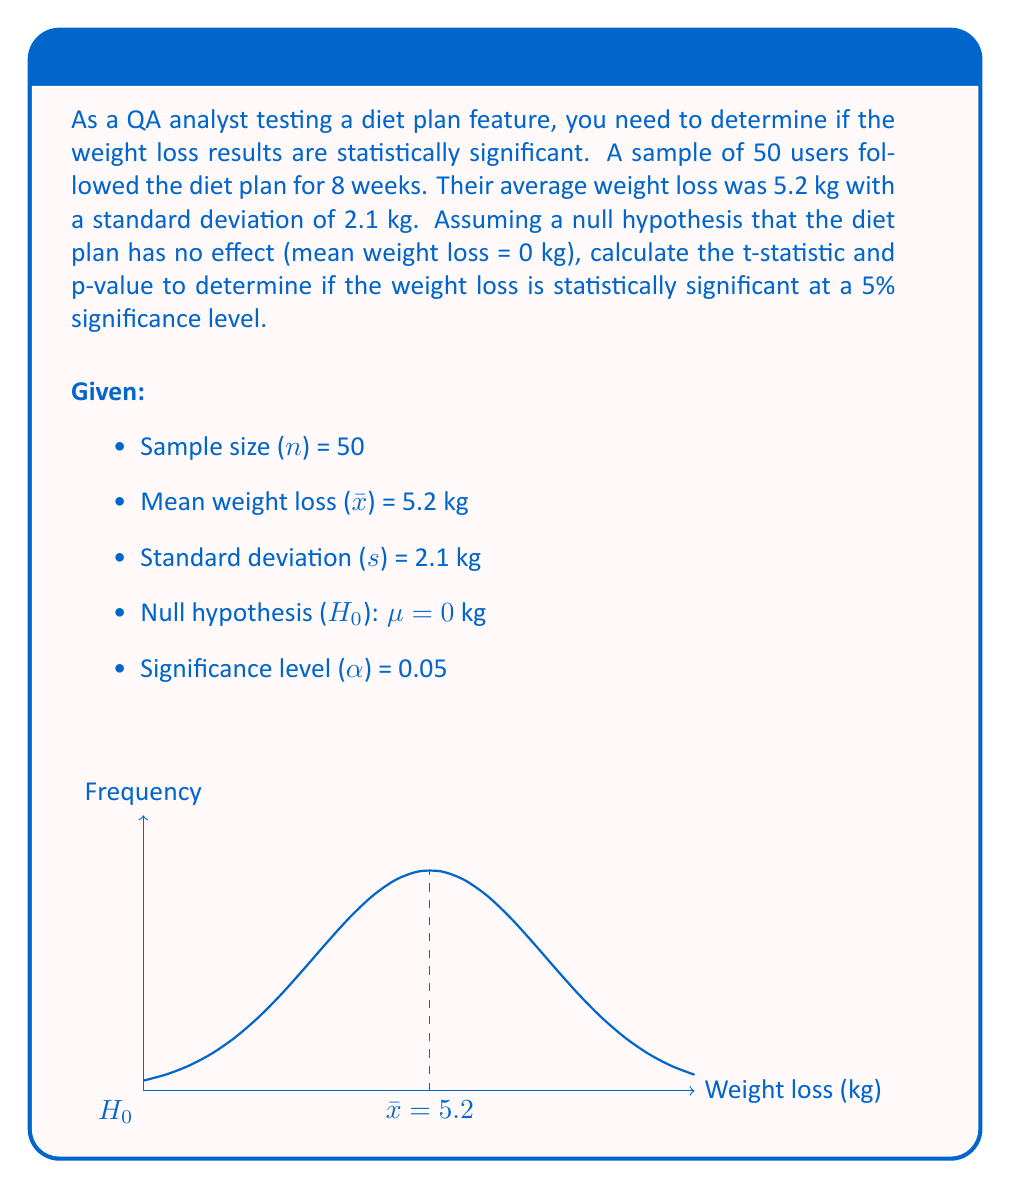Solve this math problem. To determine statistical significance, we'll follow these steps:

1. Calculate the t-statistic:
   The formula for the t-statistic is:
   $$ t = \frac{\bar{x} - \mu_0}{s / \sqrt{n}} $$
   where $\bar{x}$ is the sample mean, $\mu_0$ is the hypothesized population mean (0 in this case), $s$ is the sample standard deviation, and $n$ is the sample size.

   $$ t = \frac{5.2 - 0}{2.1 / \sqrt{50}} = \frac{5.2}{2.1 / 7.071} = 17.47 $$

2. Determine the degrees of freedom:
   df = n - 1 = 50 - 1 = 49

3. Find the critical t-value:
   For a two-tailed test at α = 0.05 and df = 49, the critical t-value is approximately ±2.010.

4. Calculate the p-value:
   Using a t-distribution calculator or table, we find that the p-value for t = 17.47 and df = 49 is p < 0.0001.

5. Compare the p-value to the significance level:
   Since p < 0.0001 is less than α = 0.05, we reject the null hypothesis.

Conclusion: The weight loss results are statistically significant at the 5% level. This means that the observed weight loss is unlikely to have occurred by chance if the diet plan had no effect.
Answer: t = 17.47, p < 0.0001; statistically significant 